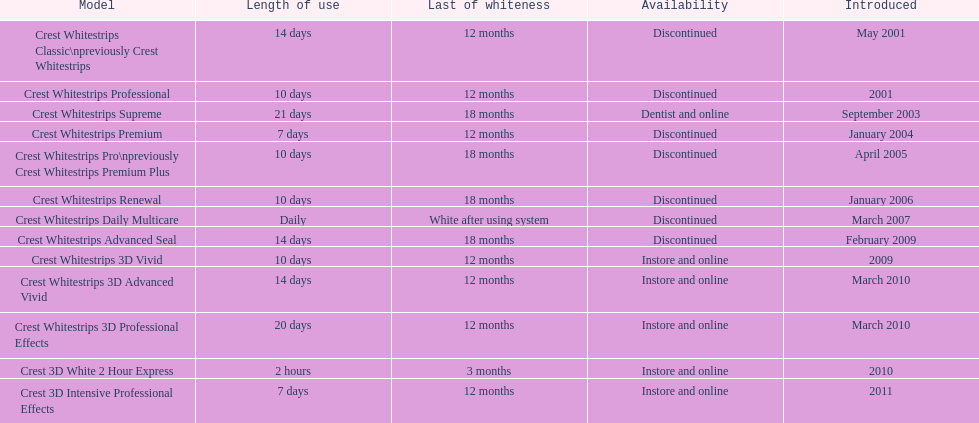What is the number of products that were introduced in 2010? 3. 